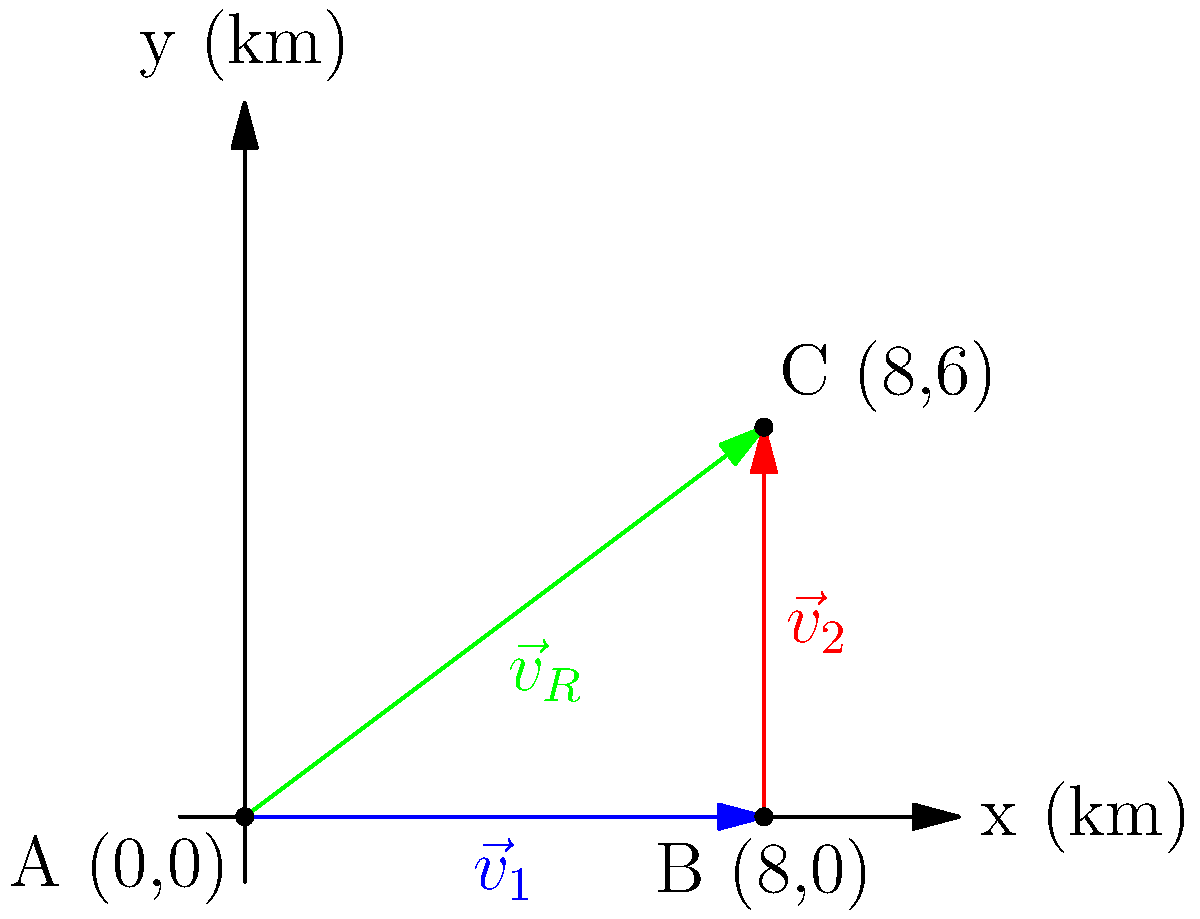In a smart city, a delivery drone needs to navigate from point A to point C. The drone first travels 8 km east to point B, then 6 km north to reach point C. Using vector addition, determine the magnitude and direction of the resultant vector $\vec{v}_R$ that represents the optimal direct path from A to C. Express the direction as an angle in degrees from the positive x-axis. Let's approach this step-by-step:

1) First, we identify our vectors:
   $\vec{v}_1 = 8\hat{i}$ (8 km east)
   $\vec{v}_2 = 6\hat{j}$ (6 km north)

2) The resultant vector $\vec{v}_R$ is the sum of these vectors:
   $\vec{v}_R = \vec{v}_1 + \vec{v}_2 = 8\hat{i} + 6\hat{j}$

3) To find the magnitude of $\vec{v}_R$, we use the Pythagorean theorem:
   $|\vec{v}_R| = \sqrt{8^2 + 6^2} = \sqrt{64 + 36} = \sqrt{100} = 10$ km

4) To find the direction, we need to calculate the angle $\theta$ from the positive x-axis:
   $\theta = \tan^{-1}(\frac{y}{x}) = \tan^{-1}(\frac{6}{8})$

5) Using a calculator or programming function:
   $\theta \approx 36.87°$

6) This angle is similar to the banking in NASCAR turns, which typically range from 12° to 36°, adding a familiar reference point.

Therefore, the optimal path for the drone is a straight line from A to C, represented by vector $\vec{v}_R$ with a magnitude of 10 km and direction of approximately 36.87° from the positive x-axis.
Answer: 10 km, 36.87° 